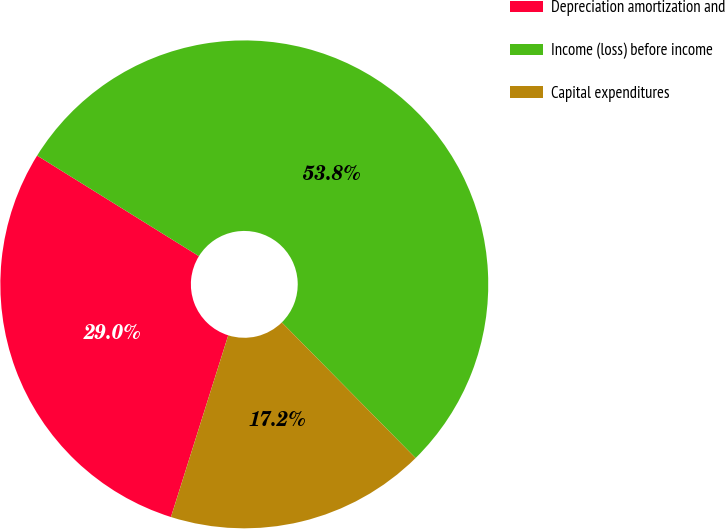<chart> <loc_0><loc_0><loc_500><loc_500><pie_chart><fcel>Depreciation amortization and<fcel>Income (loss) before income<fcel>Capital expenditures<nl><fcel>28.99%<fcel>53.76%<fcel>17.25%<nl></chart> 